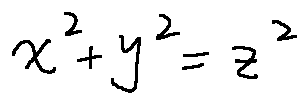Convert formula to latex. <formula><loc_0><loc_0><loc_500><loc_500>x ^ { 2 } + y ^ { 2 } = z ^ { 2 }</formula> 